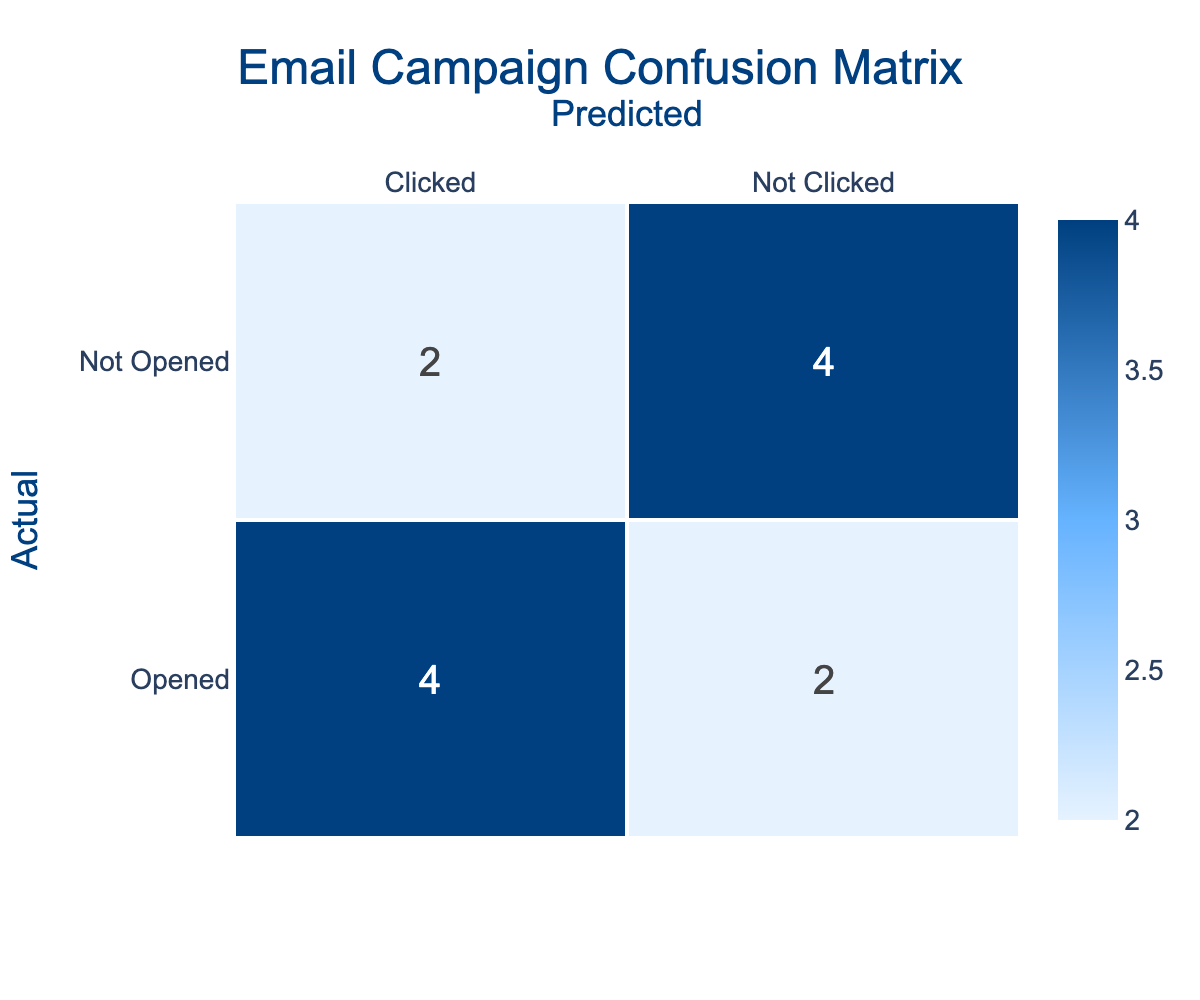What is the number of emails that were opened and clicked? From the confusion matrix, we can see that the number of emails that were both opened and clicked are in the first cell of the matrix. It indicates 5 emails, which gives us the total count directly from the matrix.
Answer: 5 What is the total number of emails that were opened? To determine the total number of emails opened, we can look at the 'Opened' row of the confusion matrix. The matrix shows that a total of 7 emails were opened, calculated by summing the values in the 'Opened' row.
Answer: 7 How many emails were sent in total? The total number of emails sent can be derived from the total number of entries in the dataset. Since there are 10 entries (one for each email), this means 10 emails were sent.
Answer: 10 What percentage of the emails that were opened were not clicked? According to the matrix, 2 emails were opened but not clicked. To find the percentage, we take the number of opened but not clicked (2) divided by the total opened emails (7), and multiply by 100, resulting in approximately 28.57%.
Answer: 28.57% Did any emails have a combination of being opened, clicked, and unsubscribed? To determine this, we check if any emails correspond to being opened and clicked while also having an unsubscribed status. From the information provided, there are no emails that meet these criteria as unsubscrptions occurred for some emails that were not opened.
Answer: No What is the difference between the number of opened emails and clicked emails? From the confusion matrix, we see that a total of 7 emails were opened and 5 emails were clicked. To find the difference, we subtract the total clicked (5) from opened (7), which results in 2.
Answer: 2 What is the total number of emails that were neither opened nor clicked? The confusion matrix indicates that there are 3 emails that fall into the 'Not Opened' and 'Not Clicked' category. This value is directly present in the matrix.
Answer: 3 How many emails were sent that did not have any unsubscribes? To find the number of emails sent without any unsubscribes, we can look at the dataset and count those emails. There are 6 emails with no unsubscribes present.
Answer: 6 What is the ratio of opened emails to not opened emails? In the confusion matrix, there are a total of 7 opened emails and 3 not opened emails. The ratio can be calculated by dividing opened (7) by not opened (3), giving a final ratio of 7:3.
Answer: 7:3 